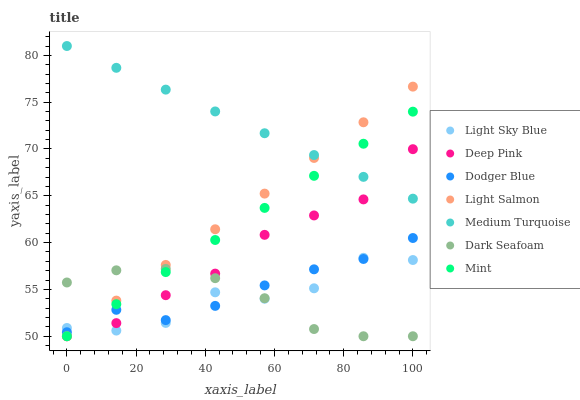Does Dark Seafoam have the minimum area under the curve?
Answer yes or no. Yes. Does Medium Turquoise have the maximum area under the curve?
Answer yes or no. Yes. Does Deep Pink have the minimum area under the curve?
Answer yes or no. No. Does Deep Pink have the maximum area under the curve?
Answer yes or no. No. Is Light Salmon the smoothest?
Answer yes or no. Yes. Is Light Sky Blue the roughest?
Answer yes or no. Yes. Is Deep Pink the smoothest?
Answer yes or no. No. Is Deep Pink the roughest?
Answer yes or no. No. Does Light Salmon have the lowest value?
Answer yes or no. Yes. Does Light Sky Blue have the lowest value?
Answer yes or no. No. Does Medium Turquoise have the highest value?
Answer yes or no. Yes. Does Deep Pink have the highest value?
Answer yes or no. No. Is Light Sky Blue less than Medium Turquoise?
Answer yes or no. Yes. Is Medium Turquoise greater than Dark Seafoam?
Answer yes or no. Yes. Does Dodger Blue intersect Light Sky Blue?
Answer yes or no. Yes. Is Dodger Blue less than Light Sky Blue?
Answer yes or no. No. Is Dodger Blue greater than Light Sky Blue?
Answer yes or no. No. Does Light Sky Blue intersect Medium Turquoise?
Answer yes or no. No. 